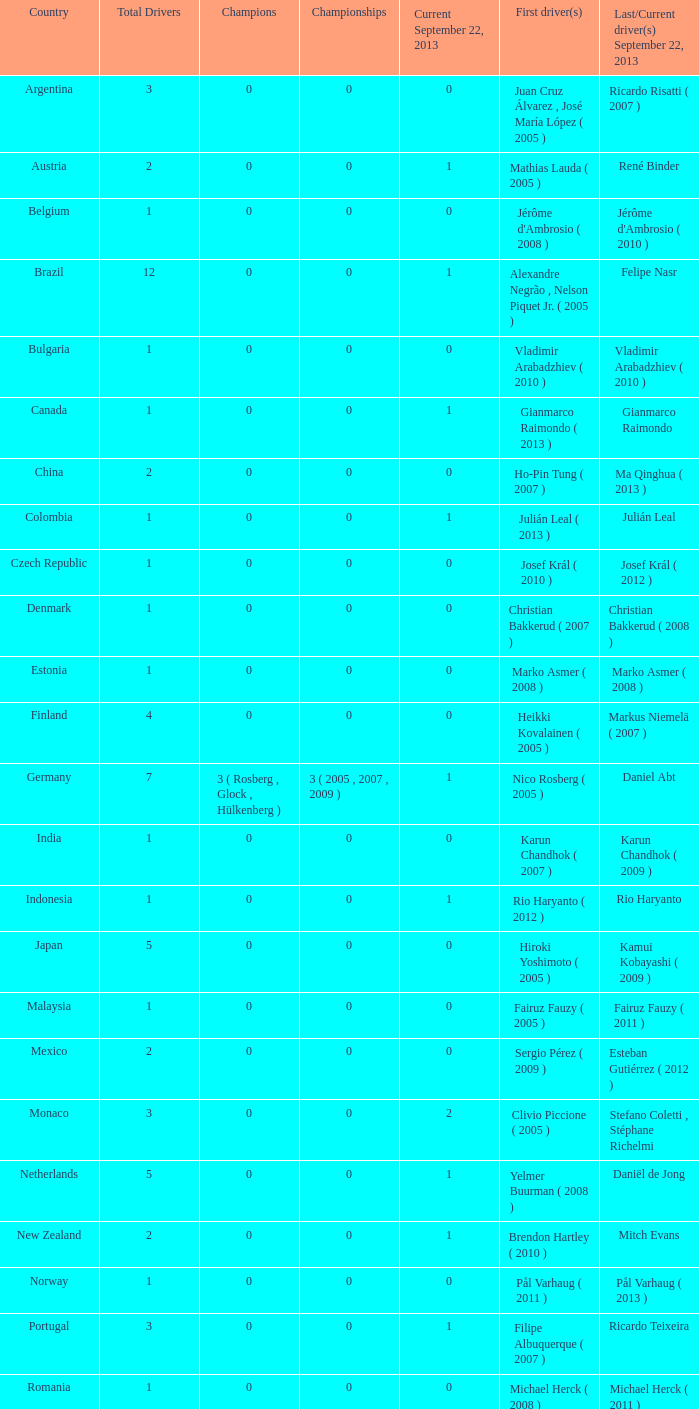How many entries are there for total drivers when the Last driver for september 22, 2013 was gianmarco raimondo? 1.0. 